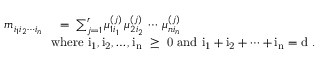<formula> <loc_0><loc_0><loc_500><loc_500>\begin{array} { r l } { m _ { i _ { 1 } i _ { 2 } \cdots i _ { n } } \, } & { = \, \sum _ { j = 1 } ^ { r } \mu _ { 1 i _ { 1 } } ^ { ( j ) } \, \mu _ { 2 i _ { 2 } } ^ { ( j ) } \, \cdots \, \mu _ { n i _ { n } } ^ { ( j ) } } \\ & { \, w h e r e i _ { 1 } , i _ { 2 } , \dots , i _ { n } \geq 0 a n d i _ { 1 } + i _ { 2 } + \cdots + i _ { n } = d . } \end{array}</formula> 